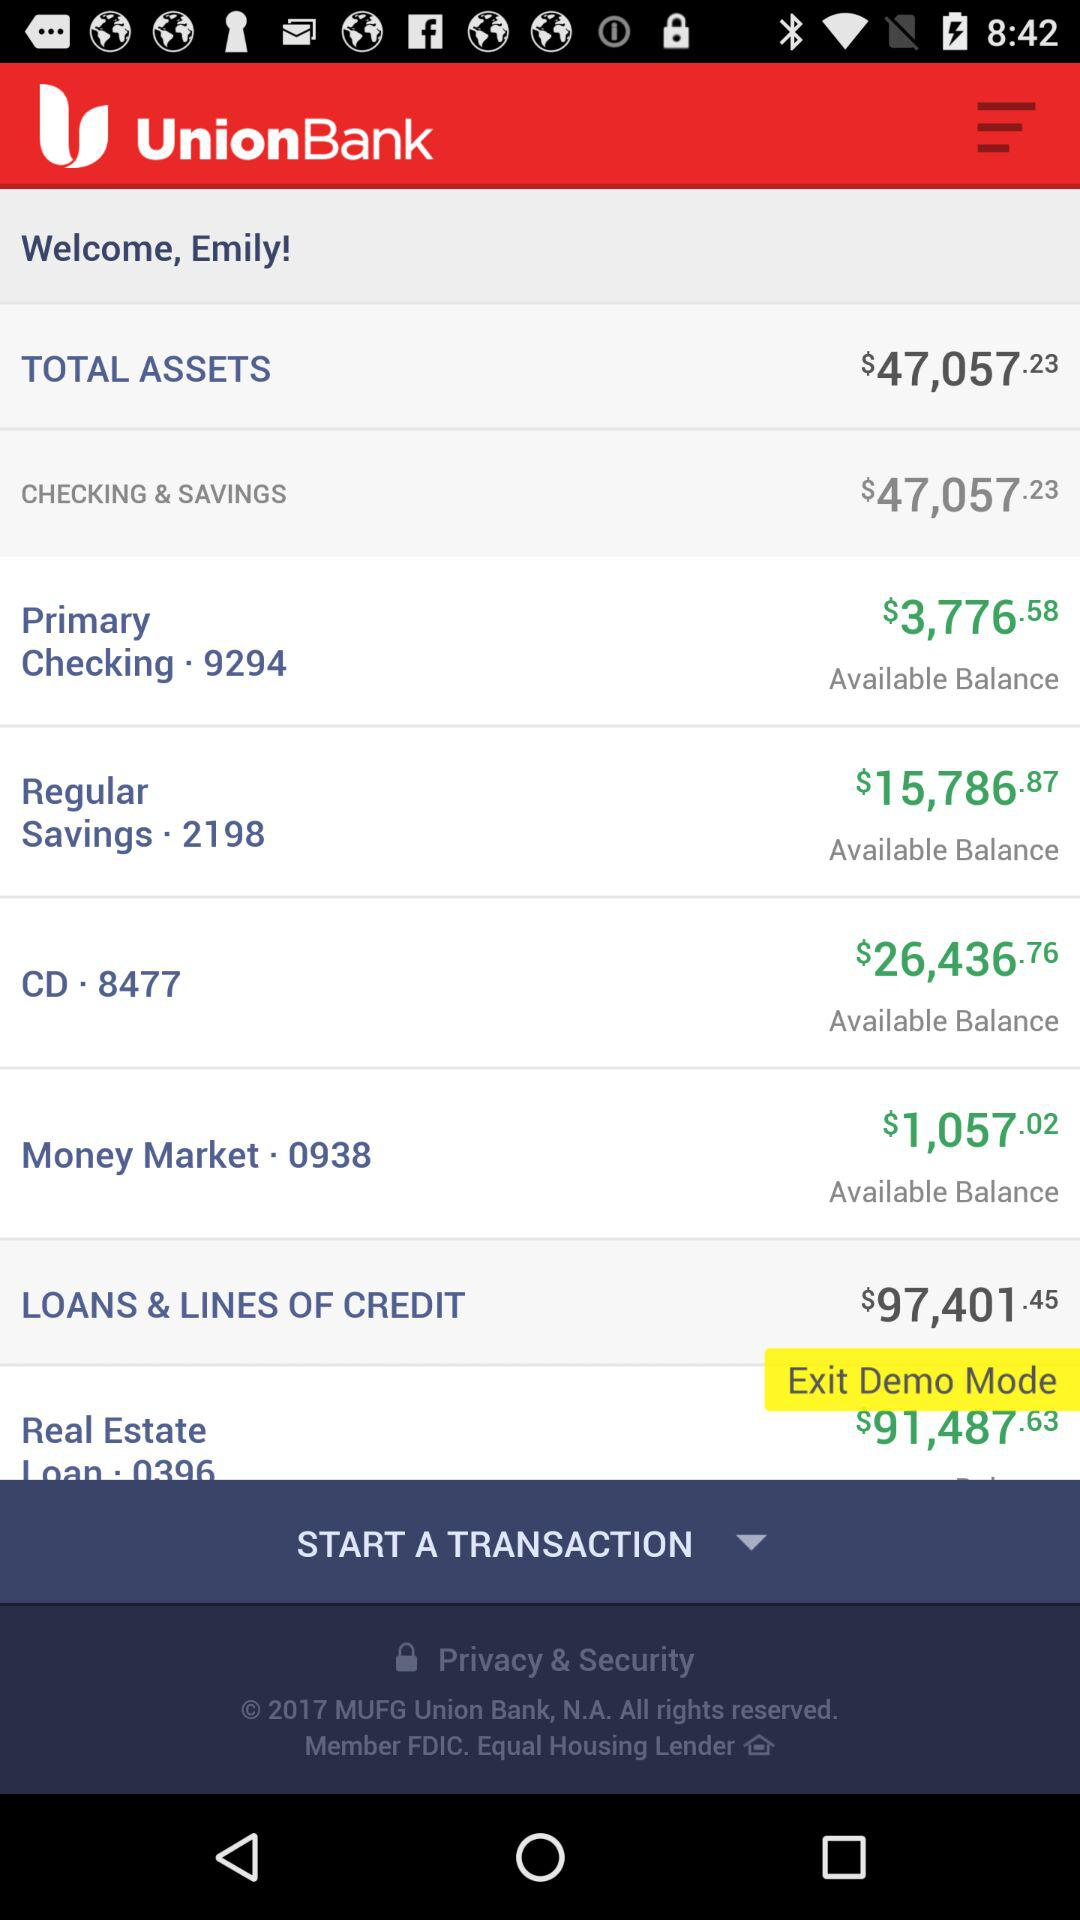How much are the total assets? The total assets are $47,057.23. 